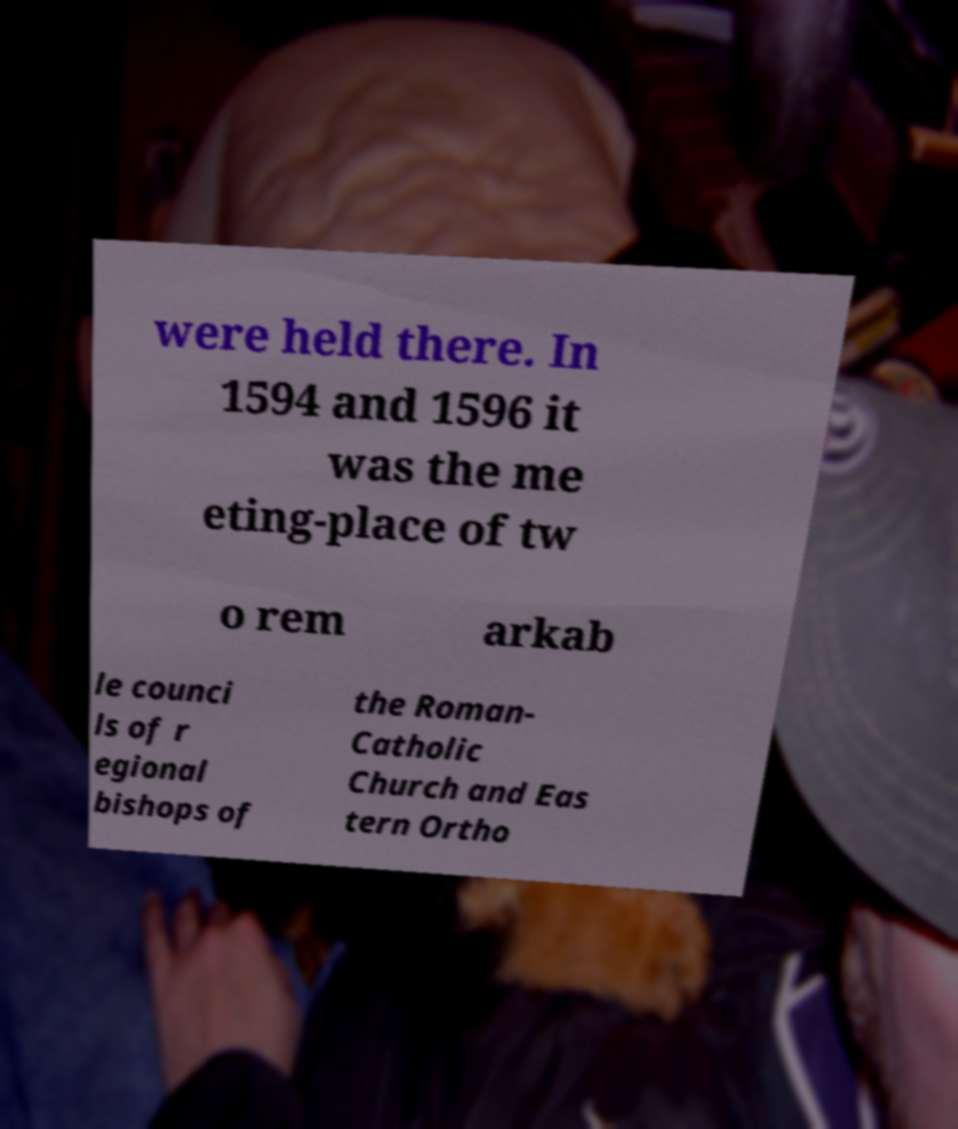For documentation purposes, I need the text within this image transcribed. Could you provide that? were held there. In 1594 and 1596 it was the me eting-place of tw o rem arkab le counci ls of r egional bishops of the Roman- Catholic Church and Eas tern Ortho 